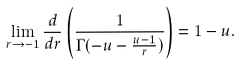<formula> <loc_0><loc_0><loc_500><loc_500>\lim _ { r \rightarrow - 1 } \frac { d } { d r } \left ( \frac { 1 } { \Gamma ( - u - \frac { u - 1 } { r } ) } \right ) = 1 - u .</formula> 